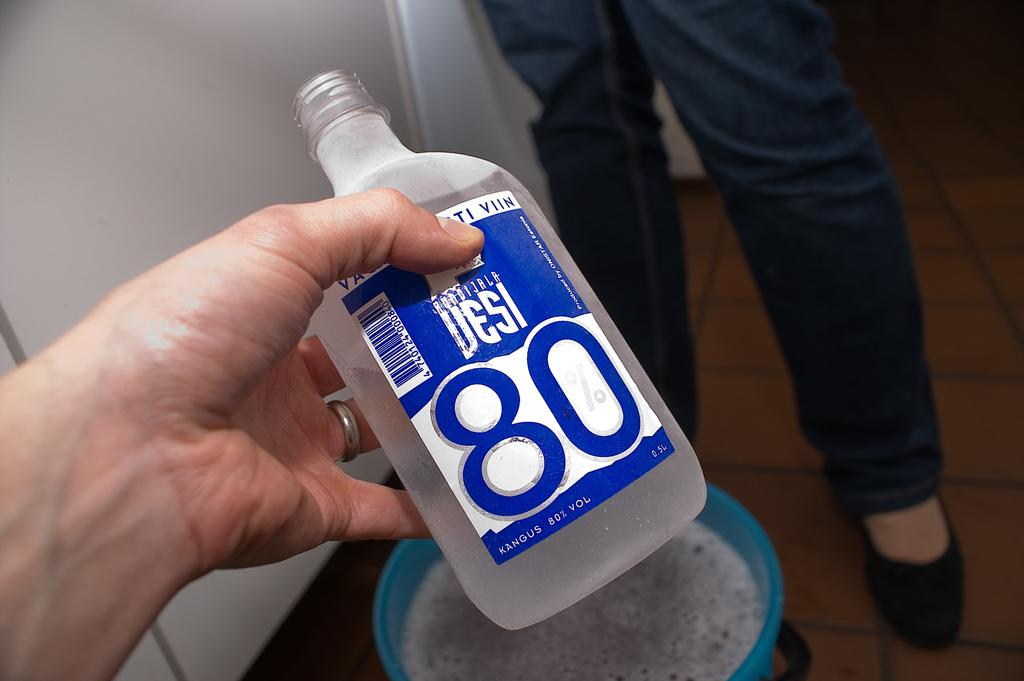<image>
Provide a brief description of the given image. A blue and white bottle contains 80% alcohol by volume. 